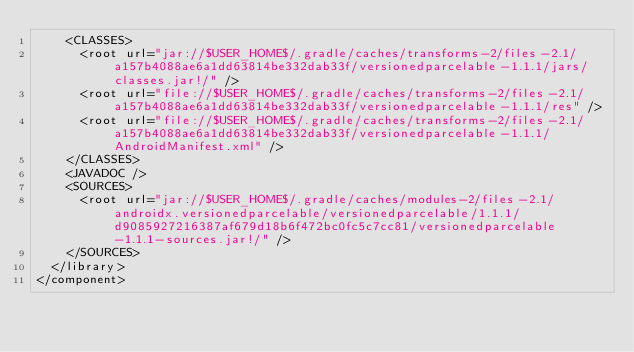Convert code to text. <code><loc_0><loc_0><loc_500><loc_500><_XML_>    <CLASSES>
      <root url="jar://$USER_HOME$/.gradle/caches/transforms-2/files-2.1/a157b4088ae6a1dd63814be332dab33f/versionedparcelable-1.1.1/jars/classes.jar!/" />
      <root url="file://$USER_HOME$/.gradle/caches/transforms-2/files-2.1/a157b4088ae6a1dd63814be332dab33f/versionedparcelable-1.1.1/res" />
      <root url="file://$USER_HOME$/.gradle/caches/transforms-2/files-2.1/a157b4088ae6a1dd63814be332dab33f/versionedparcelable-1.1.1/AndroidManifest.xml" />
    </CLASSES>
    <JAVADOC />
    <SOURCES>
      <root url="jar://$USER_HOME$/.gradle/caches/modules-2/files-2.1/androidx.versionedparcelable/versionedparcelable/1.1.1/d9085927216387af679d18b6f472bc0fc5c7cc81/versionedparcelable-1.1.1-sources.jar!/" />
    </SOURCES>
  </library>
</component></code> 